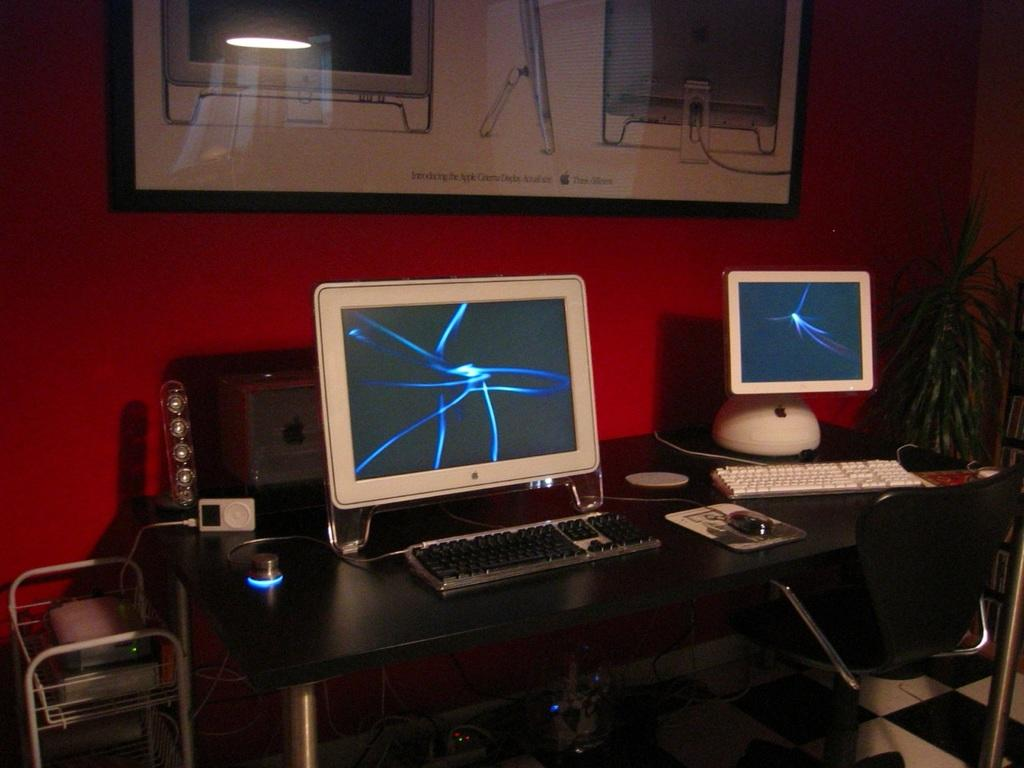What type of computers are on the table in the image? There are two Mac desktops on the table. What accessories are present for the computers? There are keyboards and mice on the table. Is there any seating near the table? Yes, there is a chair near the table. What color is the background wall in the image? The background wall is red in color. How many eggs are on the table in the image? There are no eggs present on the table in the image. What type of lumber is used to construct the table in the image? The type of lumber used to construct the table is not visible or mentioned in the image. 